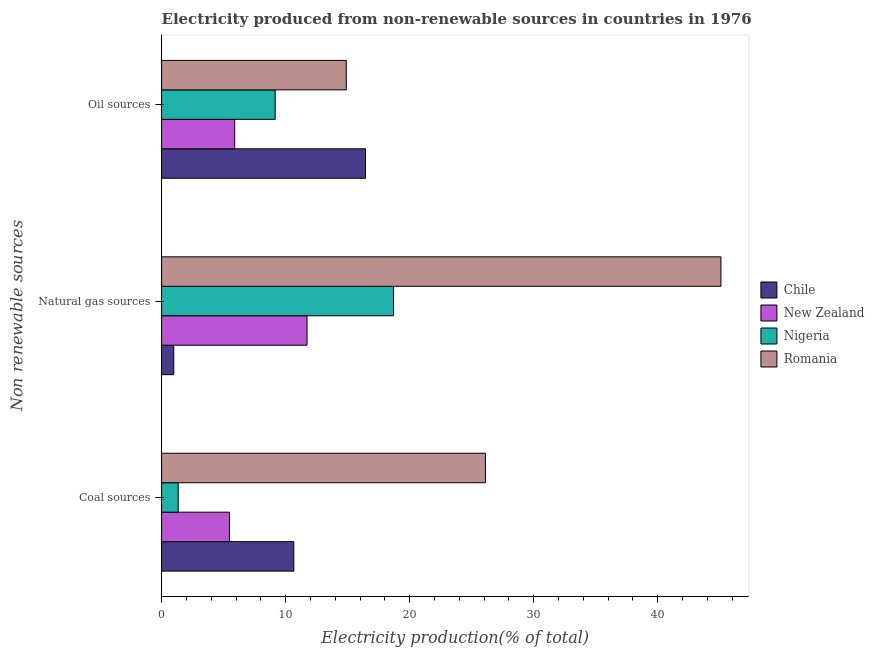How many different coloured bars are there?
Your answer should be compact. 4. Are the number of bars on each tick of the Y-axis equal?
Your answer should be compact. Yes. How many bars are there on the 1st tick from the top?
Your answer should be compact. 4. How many bars are there on the 1st tick from the bottom?
Keep it short and to the point. 4. What is the label of the 2nd group of bars from the top?
Ensure brevity in your answer.  Natural gas sources. What is the percentage of electricity produced by oil sources in Chile?
Your answer should be compact. 16.44. Across all countries, what is the maximum percentage of electricity produced by oil sources?
Provide a succinct answer. 16.44. Across all countries, what is the minimum percentage of electricity produced by natural gas?
Your answer should be compact. 0.98. In which country was the percentage of electricity produced by oil sources maximum?
Provide a short and direct response. Chile. What is the total percentage of electricity produced by oil sources in the graph?
Offer a terse response. 46.38. What is the difference between the percentage of electricity produced by natural gas in Chile and that in Nigeria?
Your response must be concise. -17.72. What is the difference between the percentage of electricity produced by coal in Nigeria and the percentage of electricity produced by natural gas in Chile?
Ensure brevity in your answer.  0.36. What is the average percentage of electricity produced by oil sources per country?
Give a very brief answer. 11.6. What is the difference between the percentage of electricity produced by oil sources and percentage of electricity produced by coal in Chile?
Provide a succinct answer. 5.78. In how many countries, is the percentage of electricity produced by coal greater than 44 %?
Keep it short and to the point. 0. What is the ratio of the percentage of electricity produced by coal in Nigeria to that in Chile?
Your response must be concise. 0.13. Is the percentage of electricity produced by natural gas in Romania less than that in Nigeria?
Make the answer very short. No. Is the difference between the percentage of electricity produced by oil sources in New Zealand and Chile greater than the difference between the percentage of electricity produced by coal in New Zealand and Chile?
Give a very brief answer. No. What is the difference between the highest and the second highest percentage of electricity produced by coal?
Your answer should be compact. 15.45. What is the difference between the highest and the lowest percentage of electricity produced by coal?
Your response must be concise. 24.77. Is the sum of the percentage of electricity produced by natural gas in Romania and New Zealand greater than the maximum percentage of electricity produced by coal across all countries?
Your answer should be compact. Yes. What does the 3rd bar from the top in Oil sources represents?
Offer a terse response. New Zealand. What does the 3rd bar from the bottom in Coal sources represents?
Provide a succinct answer. Nigeria. Is it the case that in every country, the sum of the percentage of electricity produced by coal and percentage of electricity produced by natural gas is greater than the percentage of electricity produced by oil sources?
Give a very brief answer. No. How many bars are there?
Make the answer very short. 12. Are all the bars in the graph horizontal?
Ensure brevity in your answer.  Yes. How many countries are there in the graph?
Offer a very short reply. 4. What is the difference between two consecutive major ticks on the X-axis?
Provide a succinct answer. 10. Does the graph contain any zero values?
Your answer should be very brief. No. Does the graph contain grids?
Your response must be concise. No. Where does the legend appear in the graph?
Keep it short and to the point. Center right. How many legend labels are there?
Keep it short and to the point. 4. How are the legend labels stacked?
Provide a short and direct response. Vertical. What is the title of the graph?
Offer a very short reply. Electricity produced from non-renewable sources in countries in 1976. What is the label or title of the X-axis?
Offer a terse response. Electricity production(% of total). What is the label or title of the Y-axis?
Keep it short and to the point. Non renewable sources. What is the Electricity production(% of total) of Chile in Coal sources?
Offer a very short reply. 10.66. What is the Electricity production(% of total) of New Zealand in Coal sources?
Your answer should be compact. 5.48. What is the Electricity production(% of total) in Nigeria in Coal sources?
Keep it short and to the point. 1.34. What is the Electricity production(% of total) of Romania in Coal sources?
Offer a very short reply. 26.11. What is the Electricity production(% of total) of Chile in Natural gas sources?
Keep it short and to the point. 0.98. What is the Electricity production(% of total) of New Zealand in Natural gas sources?
Offer a terse response. 11.73. What is the Electricity production(% of total) of Nigeria in Natural gas sources?
Your response must be concise. 18.7. What is the Electricity production(% of total) in Romania in Natural gas sources?
Your response must be concise. 45.09. What is the Electricity production(% of total) of Chile in Oil sources?
Provide a succinct answer. 16.44. What is the Electricity production(% of total) of New Zealand in Oil sources?
Provide a succinct answer. 5.9. What is the Electricity production(% of total) of Nigeria in Oil sources?
Ensure brevity in your answer.  9.16. What is the Electricity production(% of total) of Romania in Oil sources?
Provide a short and direct response. 14.89. Across all Non renewable sources, what is the maximum Electricity production(% of total) of Chile?
Provide a succinct answer. 16.44. Across all Non renewable sources, what is the maximum Electricity production(% of total) of New Zealand?
Offer a very short reply. 11.73. Across all Non renewable sources, what is the maximum Electricity production(% of total) of Nigeria?
Make the answer very short. 18.7. Across all Non renewable sources, what is the maximum Electricity production(% of total) of Romania?
Give a very brief answer. 45.09. Across all Non renewable sources, what is the minimum Electricity production(% of total) of Chile?
Provide a short and direct response. 0.98. Across all Non renewable sources, what is the minimum Electricity production(% of total) in New Zealand?
Keep it short and to the point. 5.48. Across all Non renewable sources, what is the minimum Electricity production(% of total) of Nigeria?
Your response must be concise. 1.34. Across all Non renewable sources, what is the minimum Electricity production(% of total) in Romania?
Make the answer very short. 14.89. What is the total Electricity production(% of total) in Chile in the graph?
Your answer should be compact. 28.08. What is the total Electricity production(% of total) of New Zealand in the graph?
Your response must be concise. 23.1. What is the total Electricity production(% of total) of Nigeria in the graph?
Provide a succinct answer. 29.2. What is the total Electricity production(% of total) in Romania in the graph?
Your answer should be very brief. 86.09. What is the difference between the Electricity production(% of total) of Chile in Coal sources and that in Natural gas sources?
Offer a terse response. 9.68. What is the difference between the Electricity production(% of total) of New Zealand in Coal sources and that in Natural gas sources?
Make the answer very short. -6.25. What is the difference between the Electricity production(% of total) in Nigeria in Coal sources and that in Natural gas sources?
Offer a very short reply. -17.36. What is the difference between the Electricity production(% of total) in Romania in Coal sources and that in Natural gas sources?
Make the answer very short. -18.99. What is the difference between the Electricity production(% of total) of Chile in Coal sources and that in Oil sources?
Keep it short and to the point. -5.78. What is the difference between the Electricity production(% of total) of New Zealand in Coal sources and that in Oil sources?
Offer a very short reply. -0.42. What is the difference between the Electricity production(% of total) in Nigeria in Coal sources and that in Oil sources?
Provide a short and direct response. -7.82. What is the difference between the Electricity production(% of total) of Romania in Coal sources and that in Oil sources?
Make the answer very short. 11.22. What is the difference between the Electricity production(% of total) in Chile in Natural gas sources and that in Oil sources?
Provide a short and direct response. -15.46. What is the difference between the Electricity production(% of total) in New Zealand in Natural gas sources and that in Oil sources?
Give a very brief answer. 5.83. What is the difference between the Electricity production(% of total) of Nigeria in Natural gas sources and that in Oil sources?
Your answer should be compact. 9.55. What is the difference between the Electricity production(% of total) in Romania in Natural gas sources and that in Oil sources?
Your answer should be very brief. 30.2. What is the difference between the Electricity production(% of total) of Chile in Coal sources and the Electricity production(% of total) of New Zealand in Natural gas sources?
Your answer should be very brief. -1.07. What is the difference between the Electricity production(% of total) of Chile in Coal sources and the Electricity production(% of total) of Nigeria in Natural gas sources?
Your answer should be very brief. -8.04. What is the difference between the Electricity production(% of total) in Chile in Coal sources and the Electricity production(% of total) in Romania in Natural gas sources?
Your response must be concise. -34.43. What is the difference between the Electricity production(% of total) of New Zealand in Coal sources and the Electricity production(% of total) of Nigeria in Natural gas sources?
Give a very brief answer. -13.23. What is the difference between the Electricity production(% of total) in New Zealand in Coal sources and the Electricity production(% of total) in Romania in Natural gas sources?
Your response must be concise. -39.62. What is the difference between the Electricity production(% of total) in Nigeria in Coal sources and the Electricity production(% of total) in Romania in Natural gas sources?
Make the answer very short. -43.75. What is the difference between the Electricity production(% of total) of Chile in Coal sources and the Electricity production(% of total) of New Zealand in Oil sources?
Provide a succinct answer. 4.76. What is the difference between the Electricity production(% of total) in Chile in Coal sources and the Electricity production(% of total) in Nigeria in Oil sources?
Provide a short and direct response. 1.5. What is the difference between the Electricity production(% of total) in Chile in Coal sources and the Electricity production(% of total) in Romania in Oil sources?
Your answer should be compact. -4.23. What is the difference between the Electricity production(% of total) in New Zealand in Coal sources and the Electricity production(% of total) in Nigeria in Oil sources?
Provide a short and direct response. -3.68. What is the difference between the Electricity production(% of total) of New Zealand in Coal sources and the Electricity production(% of total) of Romania in Oil sources?
Ensure brevity in your answer.  -9.41. What is the difference between the Electricity production(% of total) of Nigeria in Coal sources and the Electricity production(% of total) of Romania in Oil sources?
Provide a short and direct response. -13.55. What is the difference between the Electricity production(% of total) of Chile in Natural gas sources and the Electricity production(% of total) of New Zealand in Oil sources?
Offer a very short reply. -4.91. What is the difference between the Electricity production(% of total) in Chile in Natural gas sources and the Electricity production(% of total) in Nigeria in Oil sources?
Provide a short and direct response. -8.18. What is the difference between the Electricity production(% of total) of Chile in Natural gas sources and the Electricity production(% of total) of Romania in Oil sources?
Offer a terse response. -13.91. What is the difference between the Electricity production(% of total) in New Zealand in Natural gas sources and the Electricity production(% of total) in Nigeria in Oil sources?
Make the answer very short. 2.57. What is the difference between the Electricity production(% of total) of New Zealand in Natural gas sources and the Electricity production(% of total) of Romania in Oil sources?
Offer a terse response. -3.16. What is the difference between the Electricity production(% of total) of Nigeria in Natural gas sources and the Electricity production(% of total) of Romania in Oil sources?
Your answer should be very brief. 3.82. What is the average Electricity production(% of total) in Chile per Non renewable sources?
Give a very brief answer. 9.36. What is the average Electricity production(% of total) of New Zealand per Non renewable sources?
Make the answer very short. 7.7. What is the average Electricity production(% of total) of Nigeria per Non renewable sources?
Make the answer very short. 9.73. What is the average Electricity production(% of total) in Romania per Non renewable sources?
Make the answer very short. 28.7. What is the difference between the Electricity production(% of total) of Chile and Electricity production(% of total) of New Zealand in Coal sources?
Your response must be concise. 5.18. What is the difference between the Electricity production(% of total) in Chile and Electricity production(% of total) in Nigeria in Coal sources?
Provide a succinct answer. 9.32. What is the difference between the Electricity production(% of total) in Chile and Electricity production(% of total) in Romania in Coal sources?
Your answer should be very brief. -15.45. What is the difference between the Electricity production(% of total) in New Zealand and Electricity production(% of total) in Nigeria in Coal sources?
Your response must be concise. 4.14. What is the difference between the Electricity production(% of total) of New Zealand and Electricity production(% of total) of Romania in Coal sources?
Give a very brief answer. -20.63. What is the difference between the Electricity production(% of total) of Nigeria and Electricity production(% of total) of Romania in Coal sources?
Your response must be concise. -24.77. What is the difference between the Electricity production(% of total) of Chile and Electricity production(% of total) of New Zealand in Natural gas sources?
Ensure brevity in your answer.  -10.75. What is the difference between the Electricity production(% of total) of Chile and Electricity production(% of total) of Nigeria in Natural gas sources?
Give a very brief answer. -17.72. What is the difference between the Electricity production(% of total) in Chile and Electricity production(% of total) in Romania in Natural gas sources?
Provide a succinct answer. -44.11. What is the difference between the Electricity production(% of total) in New Zealand and Electricity production(% of total) in Nigeria in Natural gas sources?
Provide a short and direct response. -6.98. What is the difference between the Electricity production(% of total) in New Zealand and Electricity production(% of total) in Romania in Natural gas sources?
Your response must be concise. -33.37. What is the difference between the Electricity production(% of total) of Nigeria and Electricity production(% of total) of Romania in Natural gas sources?
Your answer should be very brief. -26.39. What is the difference between the Electricity production(% of total) of Chile and Electricity production(% of total) of New Zealand in Oil sources?
Keep it short and to the point. 10.54. What is the difference between the Electricity production(% of total) in Chile and Electricity production(% of total) in Nigeria in Oil sources?
Provide a succinct answer. 7.28. What is the difference between the Electricity production(% of total) of Chile and Electricity production(% of total) of Romania in Oil sources?
Provide a succinct answer. 1.55. What is the difference between the Electricity production(% of total) of New Zealand and Electricity production(% of total) of Nigeria in Oil sources?
Offer a very short reply. -3.26. What is the difference between the Electricity production(% of total) of New Zealand and Electricity production(% of total) of Romania in Oil sources?
Ensure brevity in your answer.  -8.99. What is the difference between the Electricity production(% of total) of Nigeria and Electricity production(% of total) of Romania in Oil sources?
Offer a very short reply. -5.73. What is the ratio of the Electricity production(% of total) in Chile in Coal sources to that in Natural gas sources?
Provide a succinct answer. 10.87. What is the ratio of the Electricity production(% of total) in New Zealand in Coal sources to that in Natural gas sources?
Ensure brevity in your answer.  0.47. What is the ratio of the Electricity production(% of total) in Nigeria in Coal sources to that in Natural gas sources?
Keep it short and to the point. 0.07. What is the ratio of the Electricity production(% of total) in Romania in Coal sources to that in Natural gas sources?
Your answer should be compact. 0.58. What is the ratio of the Electricity production(% of total) of Chile in Coal sources to that in Oil sources?
Offer a terse response. 0.65. What is the ratio of the Electricity production(% of total) of New Zealand in Coal sources to that in Oil sources?
Make the answer very short. 0.93. What is the ratio of the Electricity production(% of total) in Nigeria in Coal sources to that in Oil sources?
Provide a short and direct response. 0.15. What is the ratio of the Electricity production(% of total) of Romania in Coal sources to that in Oil sources?
Your answer should be very brief. 1.75. What is the ratio of the Electricity production(% of total) in Chile in Natural gas sources to that in Oil sources?
Provide a short and direct response. 0.06. What is the ratio of the Electricity production(% of total) in New Zealand in Natural gas sources to that in Oil sources?
Provide a succinct answer. 1.99. What is the ratio of the Electricity production(% of total) in Nigeria in Natural gas sources to that in Oil sources?
Provide a succinct answer. 2.04. What is the ratio of the Electricity production(% of total) in Romania in Natural gas sources to that in Oil sources?
Provide a short and direct response. 3.03. What is the difference between the highest and the second highest Electricity production(% of total) in Chile?
Your response must be concise. 5.78. What is the difference between the highest and the second highest Electricity production(% of total) in New Zealand?
Give a very brief answer. 5.83. What is the difference between the highest and the second highest Electricity production(% of total) in Nigeria?
Make the answer very short. 9.55. What is the difference between the highest and the second highest Electricity production(% of total) of Romania?
Keep it short and to the point. 18.99. What is the difference between the highest and the lowest Electricity production(% of total) in Chile?
Provide a succinct answer. 15.46. What is the difference between the highest and the lowest Electricity production(% of total) of New Zealand?
Offer a terse response. 6.25. What is the difference between the highest and the lowest Electricity production(% of total) of Nigeria?
Offer a very short reply. 17.36. What is the difference between the highest and the lowest Electricity production(% of total) in Romania?
Give a very brief answer. 30.2. 